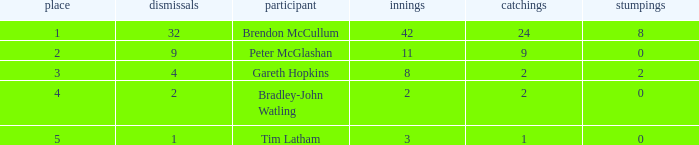List the ranks of all dismissals with a value of 4 3.0. 